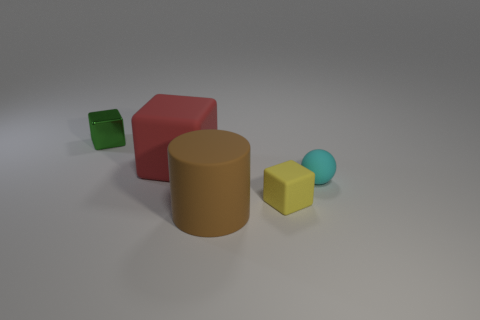Are there any purple cubes that have the same size as the cyan object?
Provide a succinct answer. No. There is a block that is the same size as the brown matte cylinder; what is it made of?
Provide a succinct answer. Rubber. How many rubber cylinders are there?
Keep it short and to the point. 1. What size is the cube that is right of the brown matte object?
Your answer should be very brief. Small. Are there an equal number of small matte cubes on the left side of the big red block and small cyan objects?
Offer a terse response. No. Are there any big brown things of the same shape as the red object?
Ensure brevity in your answer.  No. There is a matte object that is both behind the tiny yellow thing and left of the small sphere; what is its shape?
Make the answer very short. Cube. Do the large cube and the thing that is to the right of the tiny matte cube have the same material?
Offer a very short reply. Yes. There is a tiny metallic block; are there any small green shiny objects to the left of it?
Offer a very short reply. No. What number of things are either yellow matte objects or small objects to the left of the small yellow cube?
Provide a succinct answer. 2. 